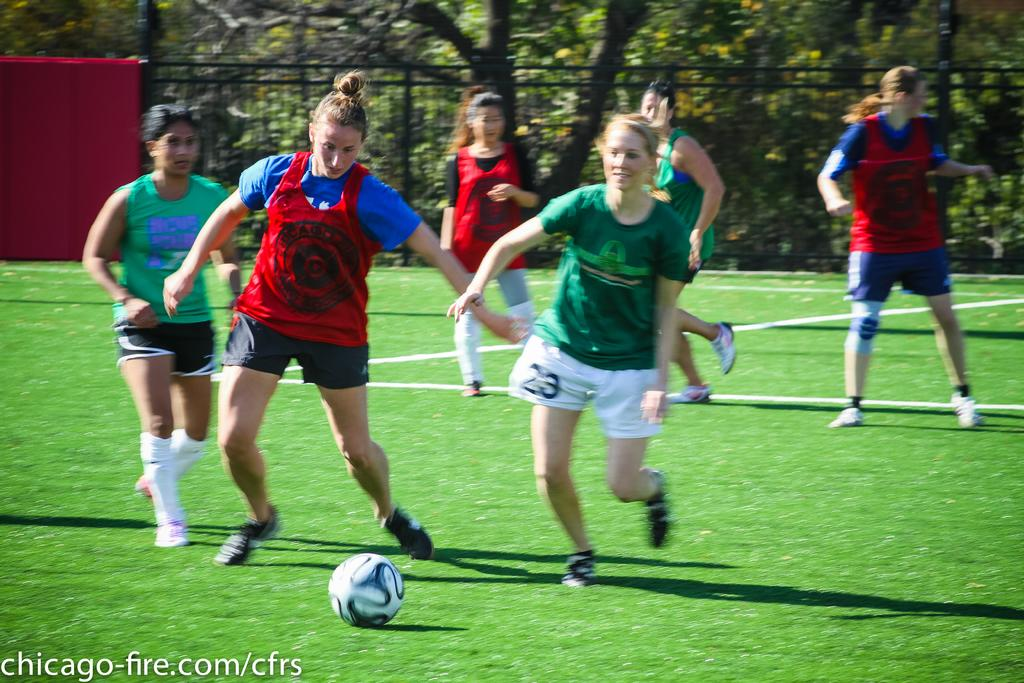<image>
Relay a brief, clear account of the picture shown. Two girls soccer teams play a game, with #23 on the green team trying to get the ball from the red Chicago player. 